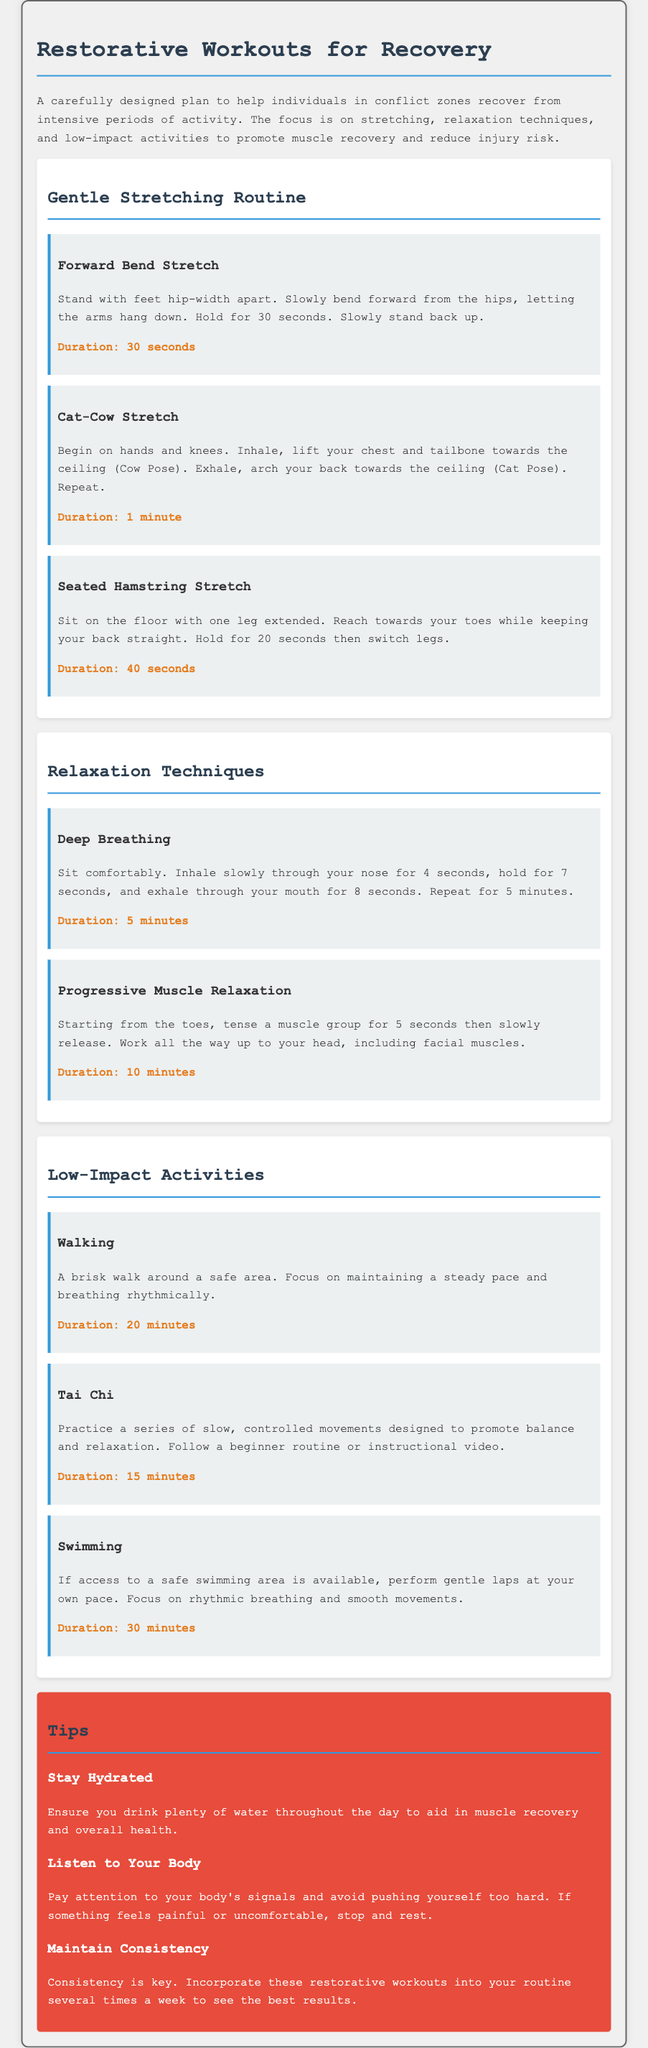what is the duration of the Forward Bend Stretch? The document specifies that the Forward Bend Stretch should be held for 30 seconds.
Answer: 30 seconds how long should you practice Deep Breathing? The document states that Deep Breathing should be repeated for 5 minutes.
Answer: 5 minutes what is the name of the technique that involves tensing and releasing muscle groups? The document refers to this technique as Progressive Muscle Relaxation.
Answer: Progressive Muscle Relaxation what kind of activities are suggested for low-impact workouts? The document lists Walking, Tai Chi, and Swimming as suggested low-impact activities.
Answer: Walking, Tai Chi, Swimming how much time is recommended for a session of Tai Chi? The document indicates that a Tai Chi session should last for 15 minutes.
Answer: 15 minutes what should you maintain to see the best results from restorative workouts? The document advises that consistency should be maintained for the best results.
Answer: Consistency how long should the Seated Hamstring Stretch be performed? According to the document, the Seated Hamstring Stretch should be held for a total of 40 seconds.
Answer: 40 seconds what is the focus of the restorative workouts mentioned in the document? The document emphasizes a focus on stretching, relaxation techniques, and low-impact activities.
Answer: Stretching, relaxation techniques, and low-impact activities 